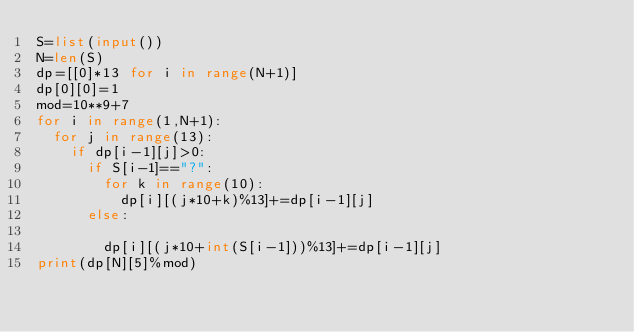Convert code to text. <code><loc_0><loc_0><loc_500><loc_500><_Python_>S=list(input())
N=len(S)
dp=[[0]*13 for i in range(N+1)]
dp[0][0]=1
mod=10**9+7
for i in range(1,N+1):
  for j in range(13):
    if dp[i-1][j]>0:
      if S[i-1]=="?":
        for k in range(10):
          dp[i][(j*10+k)%13]+=dp[i-1][j]
      else:
        
        dp[i][(j*10+int(S[i-1]))%13]+=dp[i-1][j]
print(dp[N][5]%mod)


        </code> 